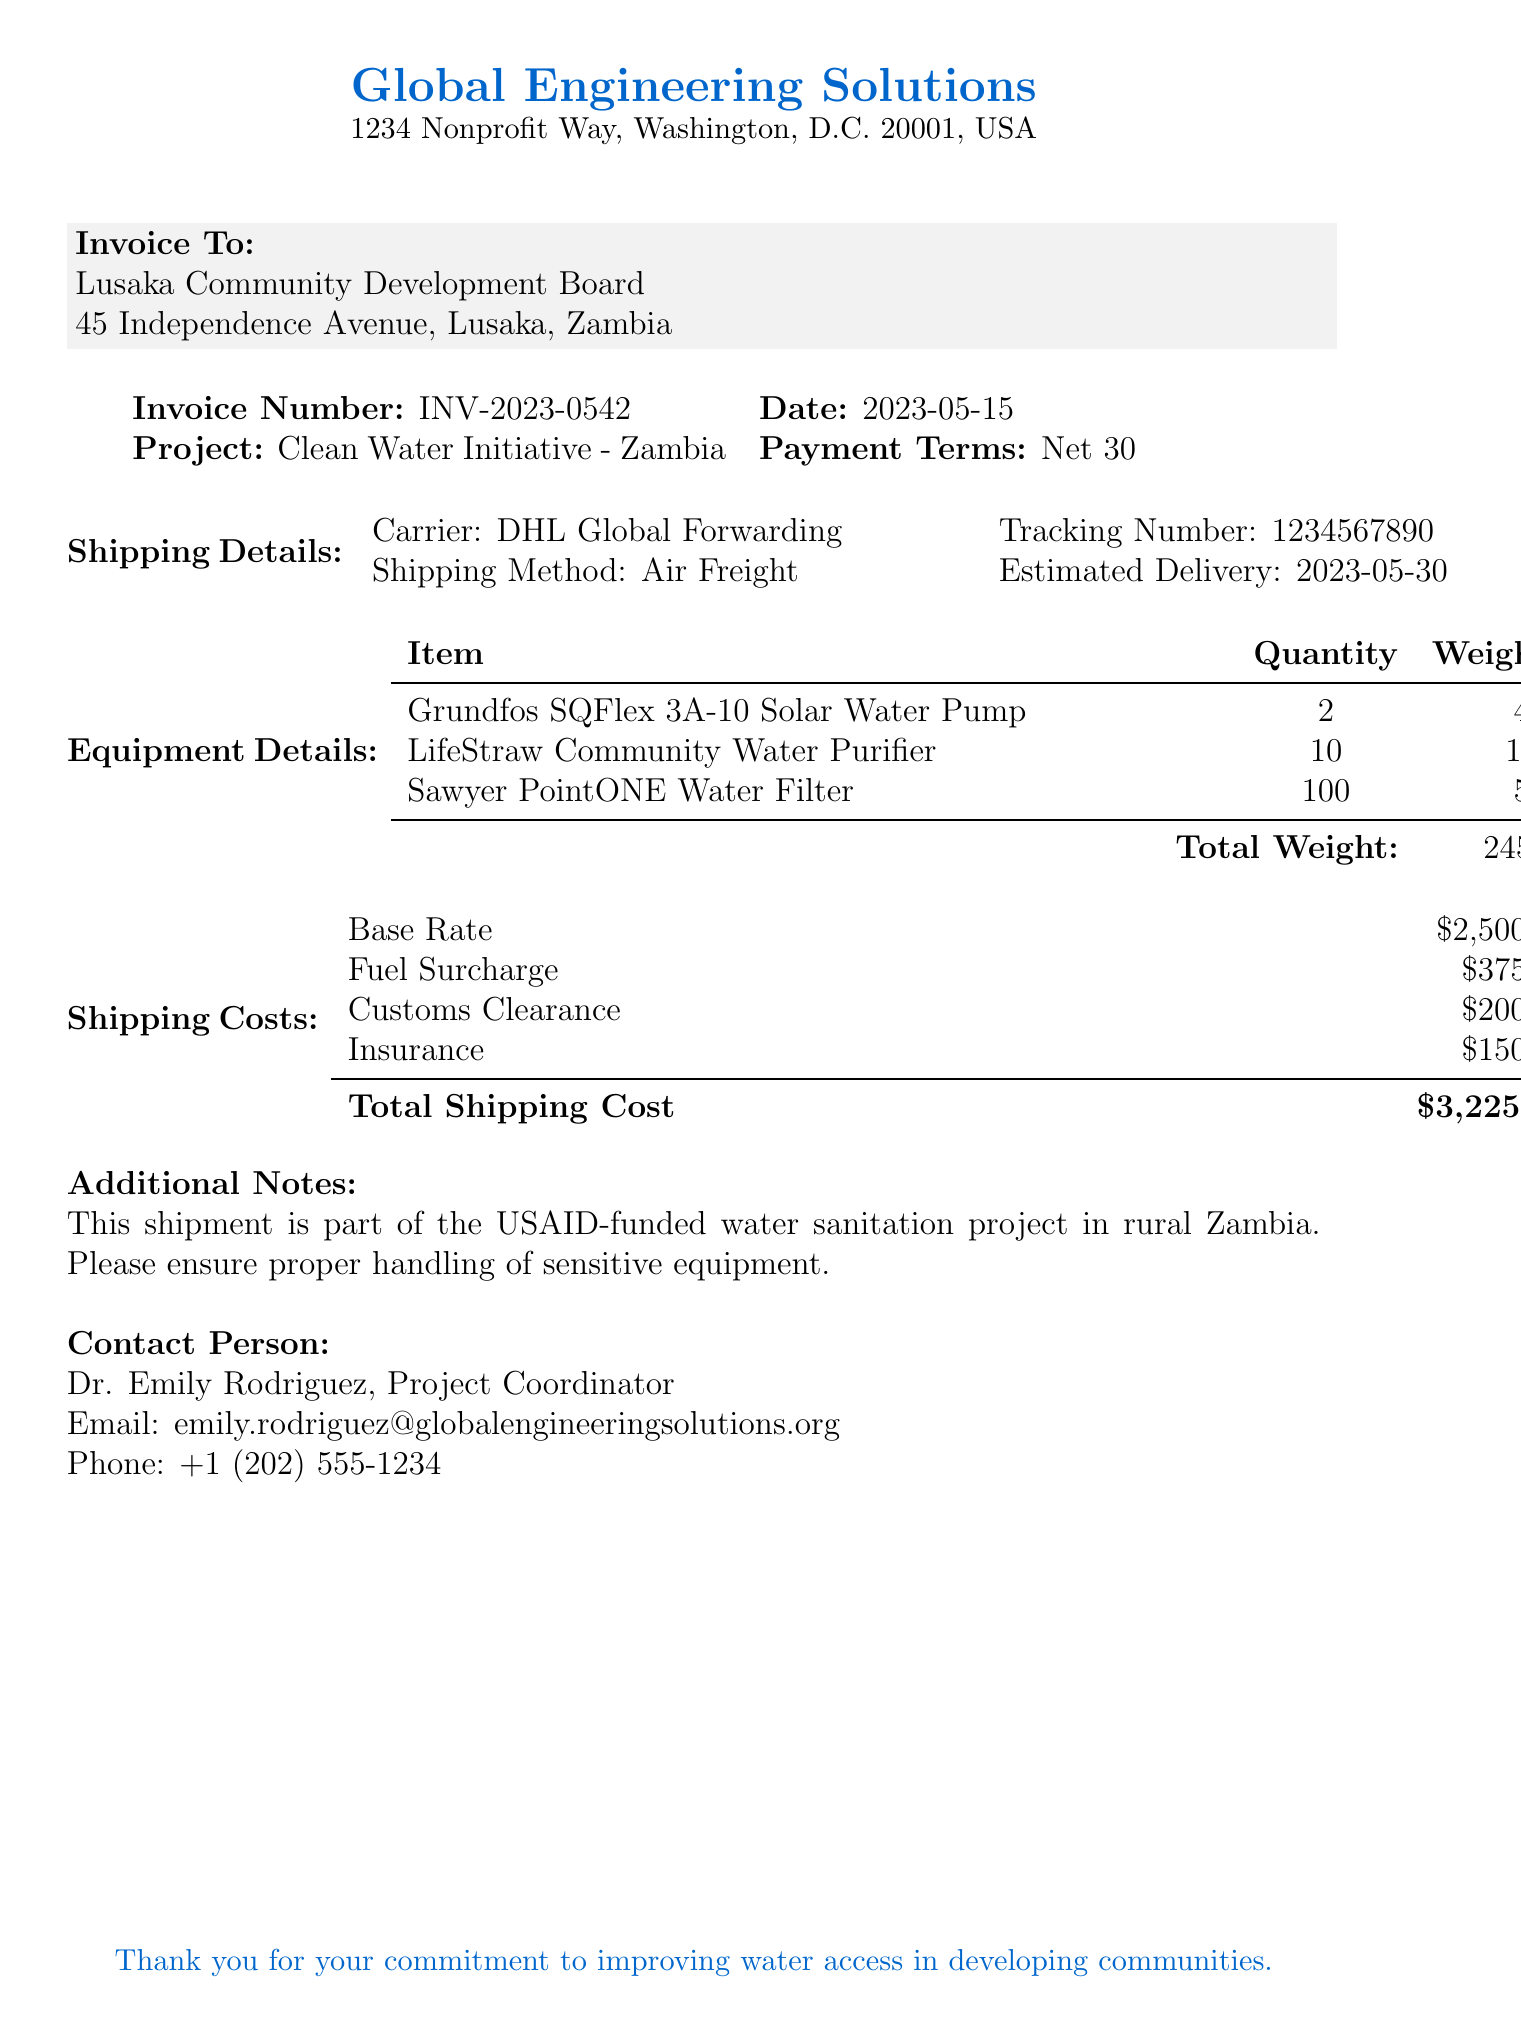What is the invoice number? The invoice number is stated in the document to identify the transaction, which is INV-2023-0542.
Answer: INV-2023-0542 What is the total shipping cost? The total shipping cost is provided in the document under shipping costs, which sums to $3225.
Answer: $3,225.00 Who is the recipient of the invoice? The recipient's details are included, indicating that the Lusaka Community Development Board is the recipient.
Answer: Lusaka Community Development Board How many LifeStraw Community Water Purifiers were shipped? The quantity of LifeStraw Community Water Purifiers is explicitly mentioned in the equipment details as 10.
Answer: 10 What is the estimated delivery date? The estimated delivery date is provided in the shipping details section, which is noted as 2023-05-30.
Answer: 2023-05-30 What is the base rate for shipping? The base rate is specified in the document as part of the shipping costs, which is $2500.
Answer: $2,500.00 What is the name of the contact person? The contact person's name is provided within the document, identified as Dr. Emily Rodriguez.
Answer: Dr. Emily Rodriguez What project is the invoice associated with? The project name is stated in the document, indicating this invoice is related to the Clean Water Initiative - Zambia.
Answer: Clean Water Initiative - Zambia What shipping method was used? The shipping method is detailed in the shipping details section, which identifies it as Air Freight.
Answer: Air Freight 